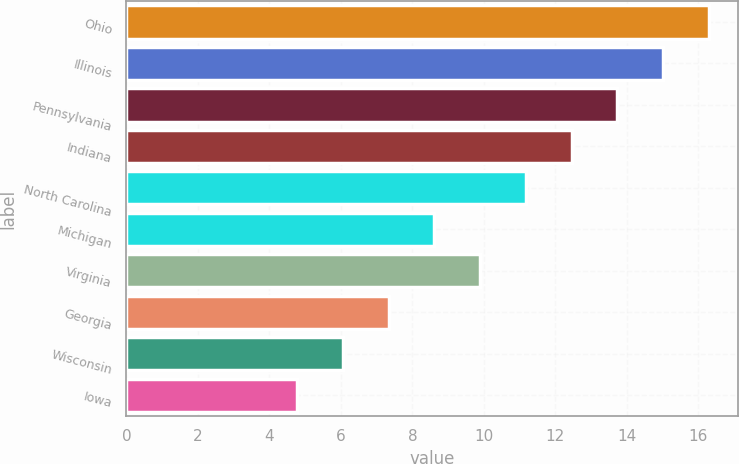Convert chart. <chart><loc_0><loc_0><loc_500><loc_500><bar_chart><fcel>Ohio<fcel>Illinois<fcel>Pennsylvania<fcel>Indiana<fcel>North Carolina<fcel>Michigan<fcel>Virginia<fcel>Georgia<fcel>Wisconsin<fcel>Iowa<nl><fcel>16.3<fcel>15.02<fcel>13.74<fcel>12.46<fcel>11.18<fcel>8.62<fcel>9.9<fcel>7.34<fcel>6.06<fcel>4.78<nl></chart> 